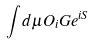Convert formula to latex. <formula><loc_0><loc_0><loc_500><loc_500>\int d \mu O _ { i } G e ^ { i S }</formula> 